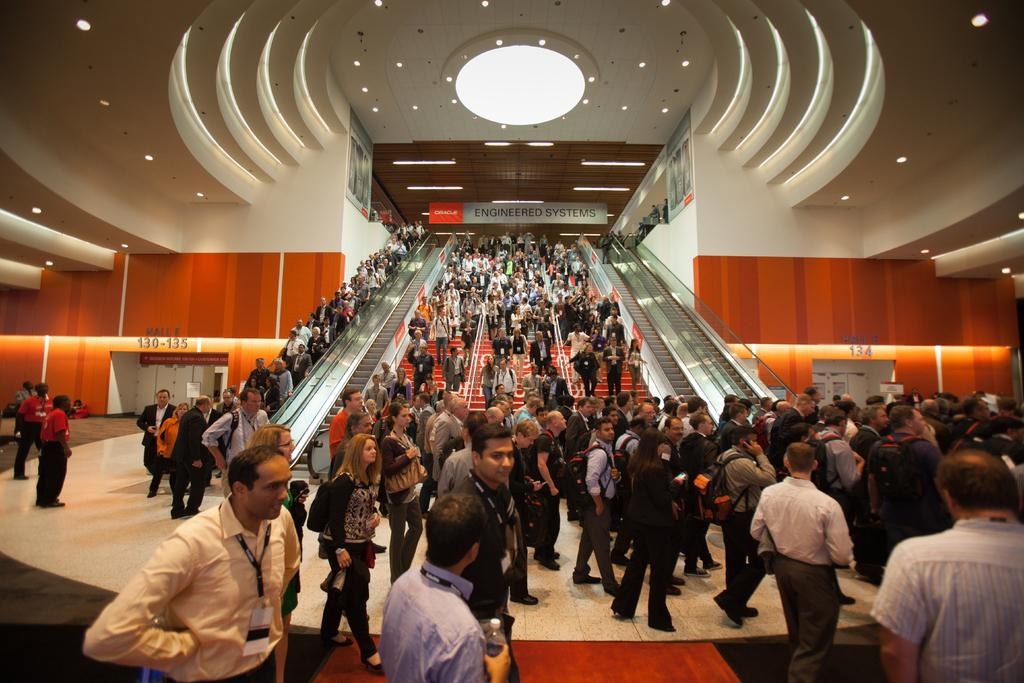How many people are in the image? There is a group of people standing in the image. What can be seen in the image besides the people? There are lights, boards, escalators, stairs, and iron rods in the image. What type of transportation is available in the image? Escalators and stairs are available for transportation in the image. What material are the rods made of? The iron rods in the image are made of metal. What type of record is being played in the image? There is no record player or record visible in the image. What suggestion can be made to improve the lighting in the image? The image does not require any suggestions for improvement, as it is a static representation. 